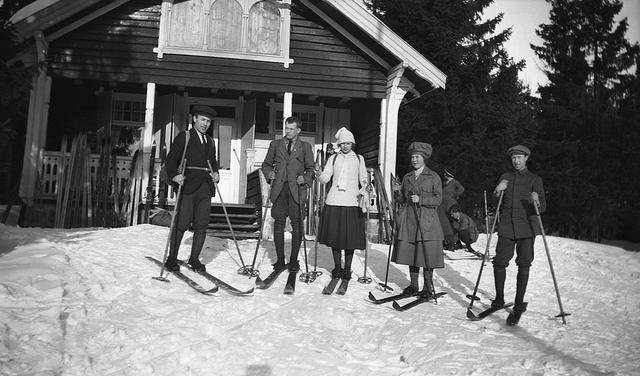Are the women wearing skirts?
Short answer required. Yes. How many men are wearing skis?
Keep it brief. 3. Do any of these skiers appear to be moving?
Be succinct. No. 